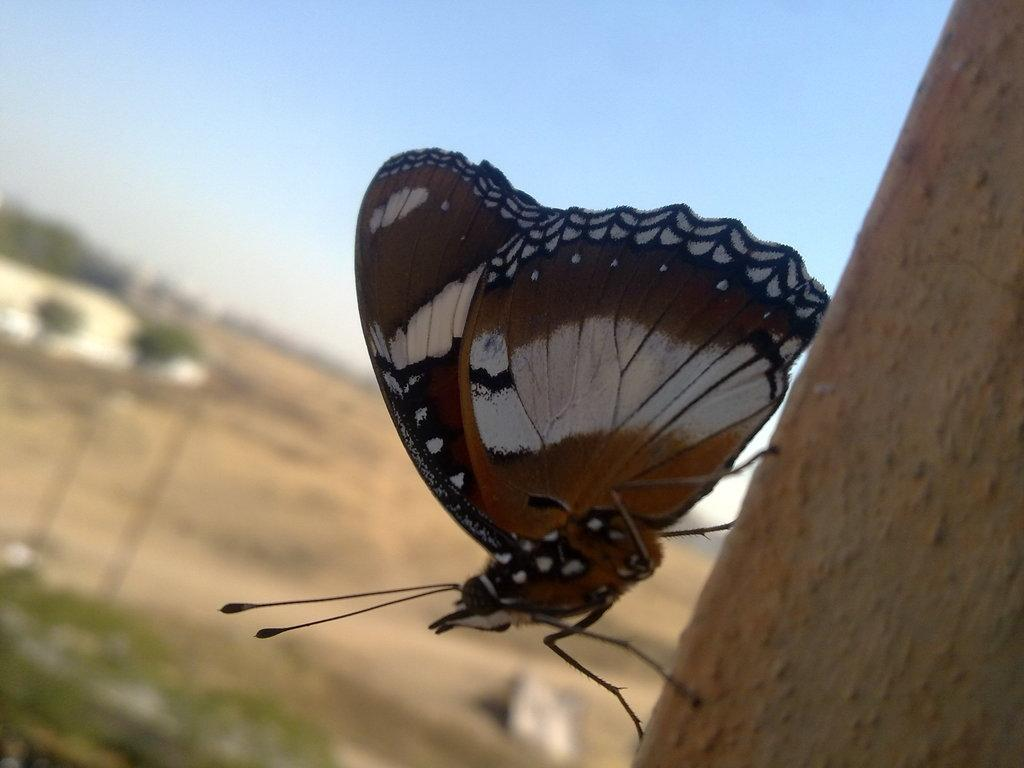What is the main subject of the image? There is a butterfly in the image. What is the butterfly resting on? The butterfly is on a brown surface. Can you describe the colors of the butterfly? The butterfly has brown, white, and black colors. What can be seen in the background of the image? There are trees and the sky visible in the background of the image. What colors are present in the sky? The sky has white and blue colors. What type of tooth is visible in the image? There is no tooth present in the image; it features a butterfly on a brown surface with trees and the sky visible in the background. Is there a pipe visible in the image? There is no pipe present in the image. 